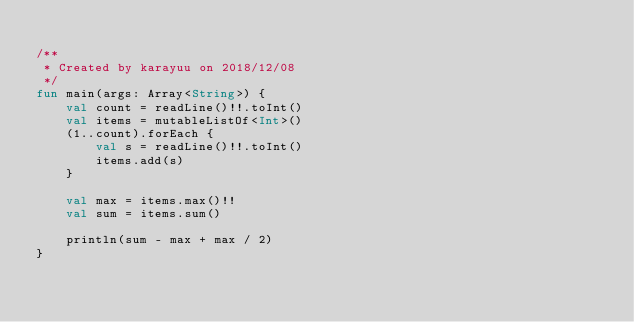Convert code to text. <code><loc_0><loc_0><loc_500><loc_500><_Kotlin_>
/**
 * Created by karayuu on 2018/12/08
 */
fun main(args: Array<String>) {
    val count = readLine()!!.toInt()
    val items = mutableListOf<Int>()
    (1..count).forEach {
        val s = readLine()!!.toInt()
        items.add(s)
    }

    val max = items.max()!!
    val sum = items.sum()

    println(sum - max + max / 2)
}
</code> 